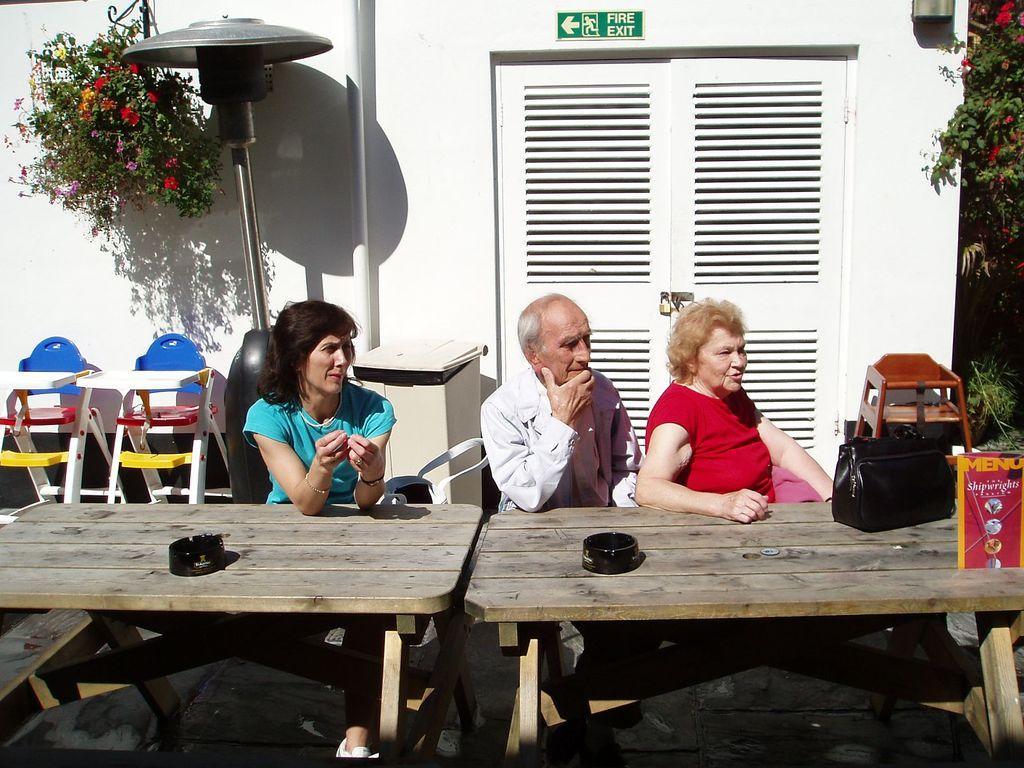Please provide a concise description of this image. As we can see in the image there is a plant, white color wall, door, three people sitting on chairs and a table. 